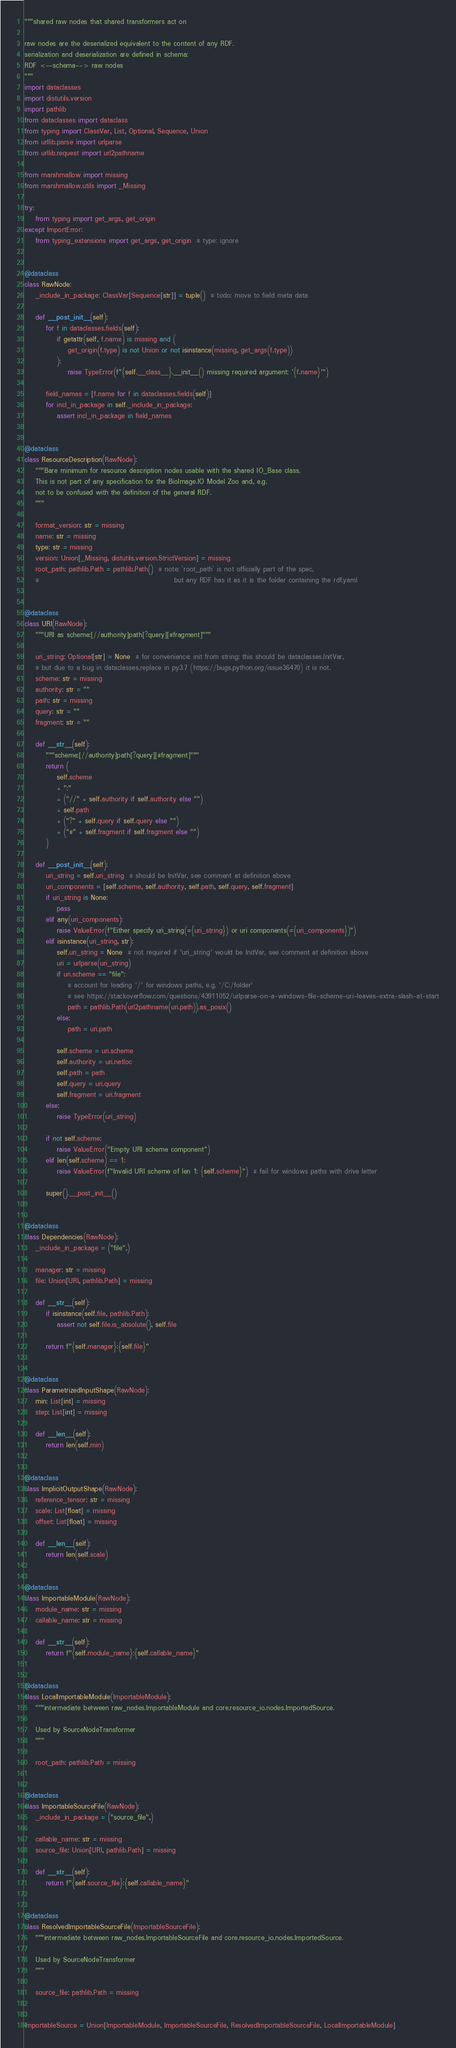Convert code to text. <code><loc_0><loc_0><loc_500><loc_500><_Python_>"""shared raw nodes that shared transformers act on

raw nodes are the deserialized equivalent to the content of any RDF.
serialization and deserialization are defined in schema:
RDF <--schema--> raw nodes
"""
import dataclasses
import distutils.version
import pathlib
from dataclasses import dataclass
from typing import ClassVar, List, Optional, Sequence, Union
from urllib.parse import urlparse
from urllib.request import url2pathname

from marshmallow import missing
from marshmallow.utils import _Missing

try:
    from typing import get_args, get_origin
except ImportError:
    from typing_extensions import get_args, get_origin  # type: ignore


@dataclass
class RawNode:
    _include_in_package: ClassVar[Sequence[str]] = tuple()  # todo: move to field meta data

    def __post_init__(self):
        for f in dataclasses.fields(self):
            if getattr(self, f.name) is missing and (
                get_origin(f.type) is not Union or not isinstance(missing, get_args(f.type))
            ):
                raise TypeError(f"{self.__class__}.__init__() missing required argument: '{f.name}'")

        field_names = [f.name for f in dataclasses.fields(self)]
        for incl_in_package in self._include_in_package:
            assert incl_in_package in field_names


@dataclass
class ResourceDescription(RawNode):
    """Bare minimum for resource description nodes usable with the shared IO_Base class.
    This is not part of any specification for the BioImage.IO Model Zoo and, e.g.
    not to be confused with the definition of the general RDF.
    """

    format_version: str = missing
    name: str = missing
    type: str = missing
    version: Union[_Missing, distutils.version.StrictVersion] = missing
    root_path: pathlib.Path = pathlib.Path()  # note: `root_path` is not officially part of the spec,
    #                                                  but any RDF has it as it is the folder containing the rdf.yaml


@dataclass
class URI(RawNode):
    """URI as scheme:[//authority]path[?query][#fragment]"""

    uri_string: Optional[str] = None  # for convenience: init from string; this should be dataclasses.InitVar,
    # but due to a bug in dataclasses.replace in py3.7 (https://bugs.python.org/issue36470) it is not.
    scheme: str = missing
    authority: str = ""
    path: str = missing
    query: str = ""
    fragment: str = ""

    def __str__(self):
        """scheme:[//authority]path[?query][#fragment]"""
        return (
            self.scheme
            + ":"
            + ("//" + self.authority if self.authority else "")
            + self.path
            + ("?" + self.query if self.query else "")
            + ("#" + self.fragment if self.fragment else "")
        )

    def __post_init__(self):
        uri_string = self.uri_string  # should be InitVar, see comment at definition above
        uri_components = [self.scheme, self.authority, self.path, self.query, self.fragment]
        if uri_string is None:
            pass
        elif any(uri_components):
            raise ValueError(f"Either specify uri_string(={uri_string}) or uri components(={uri_components})")
        elif isinstance(uri_string, str):
            self.uri_string = None  # not required if 'uri_string' would be InitVar, see comment at definition above
            uri = urlparse(uri_string)
            if uri.scheme == "file":
                # account for leading '/' for windows paths, e.g. '/C:/folder'
                # see https://stackoverflow.com/questions/43911052/urlparse-on-a-windows-file-scheme-uri-leaves-extra-slash-at-start
                path = pathlib.Path(url2pathname(uri.path)).as_posix()
            else:
                path = uri.path

            self.scheme = uri.scheme
            self.authority = uri.netloc
            self.path = path
            self.query = uri.query
            self.fragment = uri.fragment
        else:
            raise TypeError(uri_string)

        if not self.scheme:
            raise ValueError("Empty URI scheme component")
        elif len(self.scheme) == 1:
            raise ValueError(f"Invalid URI scheme of len 1: {self.scheme}")  # fail for windows paths with drive letter

        super().__post_init__()


@dataclass
class Dependencies(RawNode):
    _include_in_package = ("file",)

    manager: str = missing
    file: Union[URI, pathlib.Path] = missing

    def __str__(self):
        if isinstance(self.file, pathlib.Path):
            assert not self.file.is_absolute(), self.file

        return f"{self.manager}:{self.file}"


@dataclass
class ParametrizedInputShape(RawNode):
    min: List[int] = missing
    step: List[int] = missing

    def __len__(self):
        return len(self.min)


@dataclass
class ImplicitOutputShape(RawNode):
    reference_tensor: str = missing
    scale: List[float] = missing
    offset: List[float] = missing

    def __len__(self):
        return len(self.scale)


@dataclass
class ImportableModule(RawNode):
    module_name: str = missing
    callable_name: str = missing

    def __str__(self):
        return f"{self.module_name}:{self.callable_name}"


@dataclass
class LocalImportableModule(ImportableModule):
    """intermediate between raw_nodes.ImportableModule and core.resource_io.nodes.ImportedSource.

    Used by SourceNodeTransformer
    """

    root_path: pathlib.Path = missing


@dataclass
class ImportableSourceFile(RawNode):
    _include_in_package = ("source_file",)

    callable_name: str = missing
    source_file: Union[URI, pathlib.Path] = missing

    def __str__(self):
        return f"{self.source_file}:{self.callable_name}"


@dataclass
class ResolvedImportableSourceFile(ImportableSourceFile):
    """intermediate between raw_nodes.ImportableSourceFile and core.resource_io.nodes.ImportedSource.

    Used by SourceNodeTransformer
    """

    source_file: pathlib.Path = missing


ImportableSource = Union[ImportableModule, ImportableSourceFile, ResolvedImportableSourceFile, LocalImportableModule]
</code> 